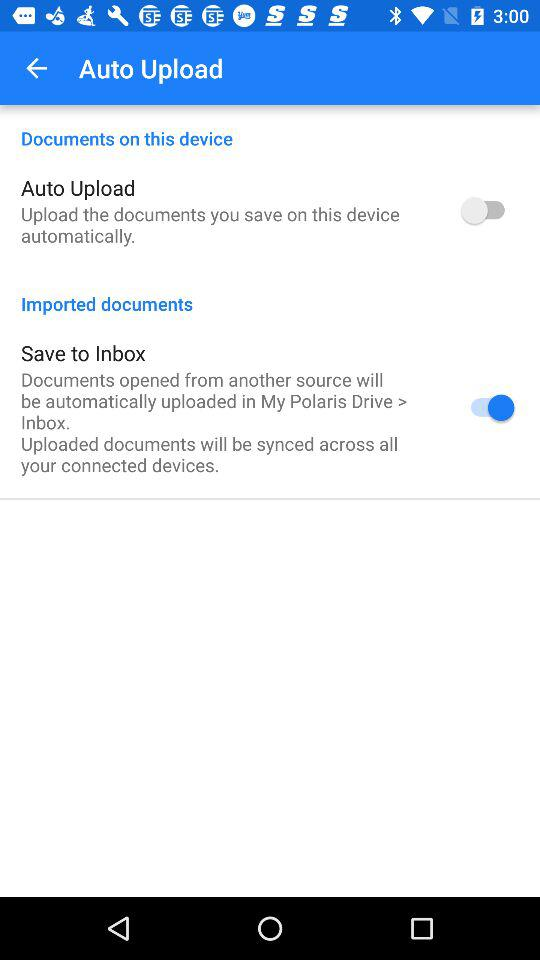What is the status of auto upload? The status of auto upload is off. 